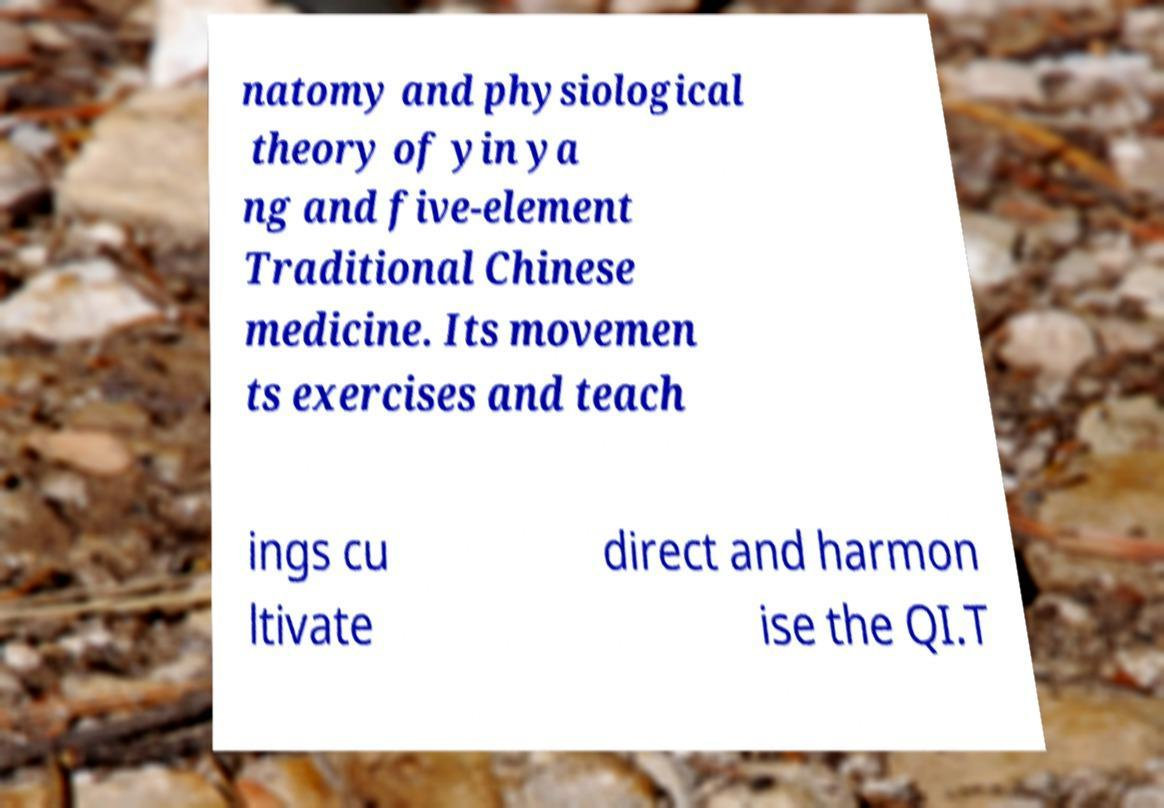Could you extract and type out the text from this image? natomy and physiological theory of yin ya ng and five-element Traditional Chinese medicine. Its movemen ts exercises and teach ings cu ltivate direct and harmon ise the QI.T 